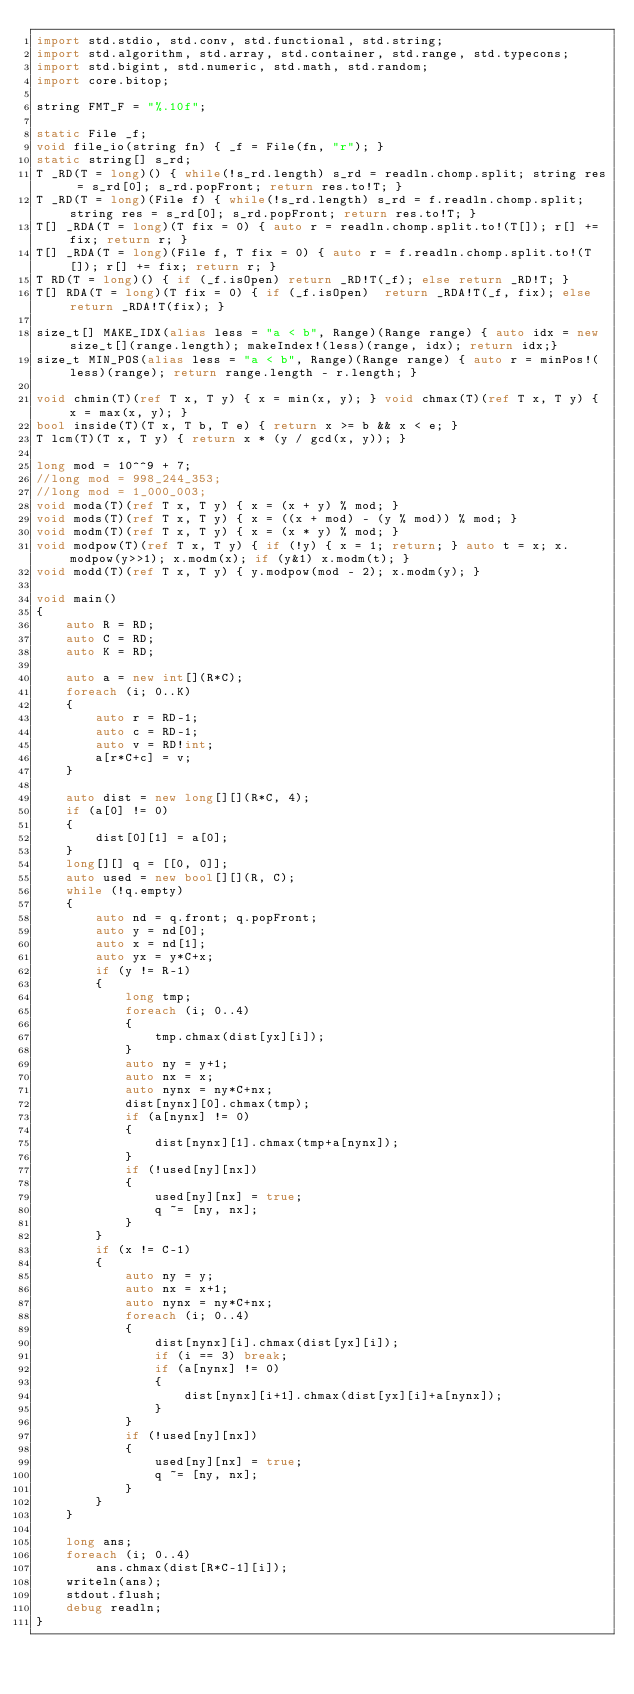<code> <loc_0><loc_0><loc_500><loc_500><_D_>import std.stdio, std.conv, std.functional, std.string;
import std.algorithm, std.array, std.container, std.range, std.typecons;
import std.bigint, std.numeric, std.math, std.random;
import core.bitop;

string FMT_F = "%.10f";

static File _f;
void file_io(string fn) { _f = File(fn, "r"); }
static string[] s_rd;
T _RD(T = long)() { while(!s_rd.length) s_rd = readln.chomp.split; string res = s_rd[0]; s_rd.popFront; return res.to!T; }
T _RD(T = long)(File f) { while(!s_rd.length) s_rd = f.readln.chomp.split; string res = s_rd[0]; s_rd.popFront; return res.to!T; }
T[] _RDA(T = long)(T fix = 0) { auto r = readln.chomp.split.to!(T[]); r[] += fix; return r; }
T[] _RDA(T = long)(File f, T fix = 0) { auto r = f.readln.chomp.split.to!(T[]); r[] += fix; return r; }
T RD(T = long)() { if (_f.isOpen) return _RD!T(_f); else return _RD!T; }
T[] RDA(T = long)(T fix = 0) { if (_f.isOpen)  return _RDA!T(_f, fix); else return _RDA!T(fix); }

size_t[] MAKE_IDX(alias less = "a < b", Range)(Range range) { auto idx = new size_t[](range.length); makeIndex!(less)(range, idx); return idx;}
size_t MIN_POS(alias less = "a < b", Range)(Range range) { auto r = minPos!(less)(range); return range.length - r.length; }

void chmin(T)(ref T x, T y) { x = min(x, y); } void chmax(T)(ref T x, T y) { x = max(x, y); }
bool inside(T)(T x, T b, T e) { return x >= b && x < e; }
T lcm(T)(T x, T y) { return x * (y / gcd(x, y)); }

long mod = 10^^9 + 7;
//long mod = 998_244_353;
//long mod = 1_000_003;
void moda(T)(ref T x, T y) { x = (x + y) % mod; }
void mods(T)(ref T x, T y) { x = ((x + mod) - (y % mod)) % mod; }
void modm(T)(ref T x, T y) { x = (x * y) % mod; }
void modpow(T)(ref T x, T y) { if (!y) { x = 1; return; } auto t = x; x.modpow(y>>1); x.modm(x); if (y&1) x.modm(t); }
void modd(T)(ref T x, T y) { y.modpow(mod - 2); x.modm(y); }

void main()
{
	auto R = RD;
	auto C = RD;
	auto K = RD;
	
	auto a = new int[](R*C);
	foreach (i; 0..K)
	{
		auto r = RD-1;
		auto c = RD-1;
		auto v = RD!int;
		a[r*C+c] = v;
	}

	auto dist = new long[][](R*C, 4);
	if (a[0] != 0)
	{
		dist[0][1] = a[0];
	}
	long[][] q = [[0, 0]];
	auto used = new bool[][](R, C);
	while (!q.empty)
	{
		auto nd = q.front; q.popFront;
		auto y = nd[0];
		auto x = nd[1];
		auto yx = y*C+x;
		if (y != R-1)
		{
			long tmp;
			foreach (i; 0..4)
			{
				tmp.chmax(dist[yx][i]);
			}
			auto ny = y+1;
			auto nx = x;
			auto nynx = ny*C+nx;
			dist[nynx][0].chmax(tmp);
			if (a[nynx] != 0)
			{
				dist[nynx][1].chmax(tmp+a[nynx]);
			}
			if (!used[ny][nx])
			{
				used[ny][nx] = true;
				q ~= [ny, nx];
			}
		}
		if (x != C-1)
		{
			auto ny = y;
			auto nx = x+1;
			auto nynx = ny*C+nx;
			foreach (i; 0..4)
			{
				dist[nynx][i].chmax(dist[yx][i]);
				if (i == 3) break;
				if (a[nynx] != 0)
				{
					dist[nynx][i+1].chmax(dist[yx][i]+a[nynx]);
				}
			}
			if (!used[ny][nx])
			{
				used[ny][nx] = true;
				q ~= [ny, nx];
			}
		}
	}

	long ans;
	foreach (i; 0..4)
		ans.chmax(dist[R*C-1][i]);
	writeln(ans);
	stdout.flush;
	debug readln;
}</code> 